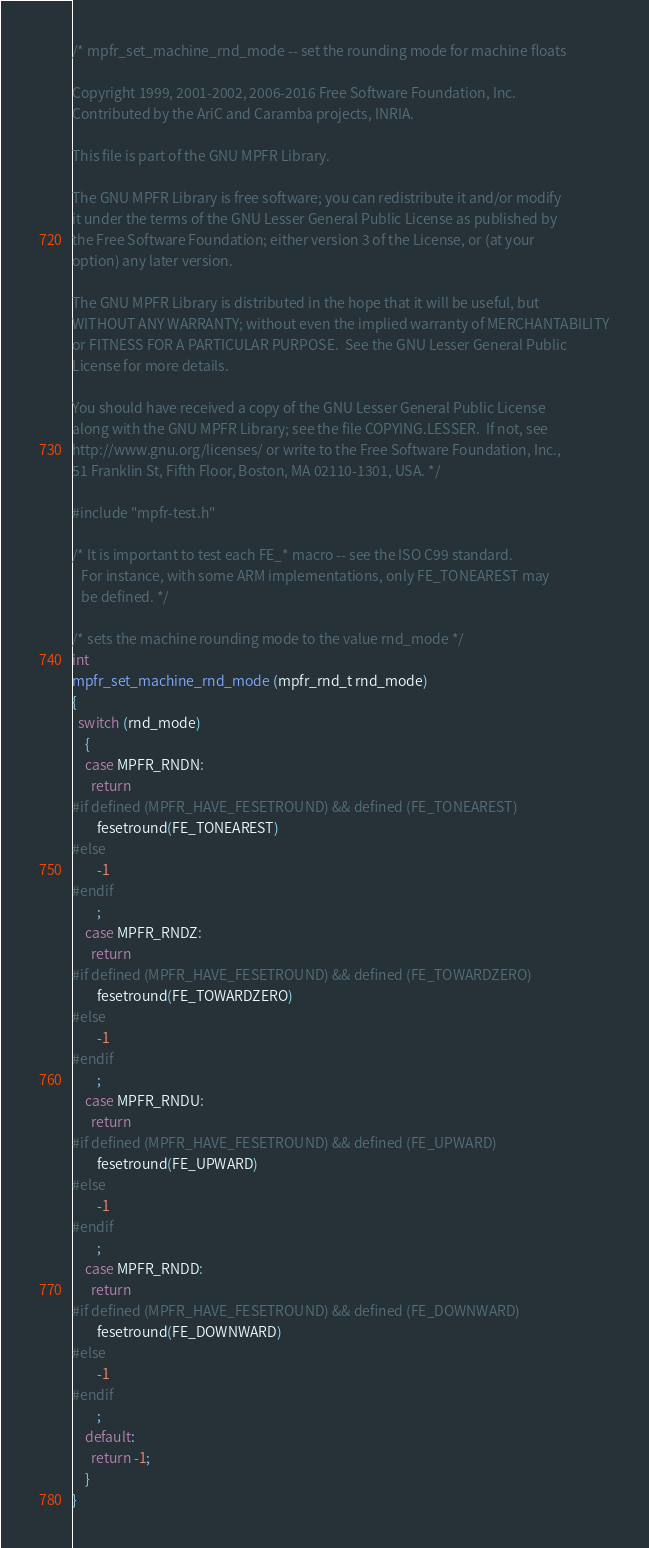Convert code to text. <code><loc_0><loc_0><loc_500><loc_500><_C_>/* mpfr_set_machine_rnd_mode -- set the rounding mode for machine floats

Copyright 1999, 2001-2002, 2006-2016 Free Software Foundation, Inc.
Contributed by the AriC and Caramba projects, INRIA.

This file is part of the GNU MPFR Library.

The GNU MPFR Library is free software; you can redistribute it and/or modify
it under the terms of the GNU Lesser General Public License as published by
the Free Software Foundation; either version 3 of the License, or (at your
option) any later version.

The GNU MPFR Library is distributed in the hope that it will be useful, but
WITHOUT ANY WARRANTY; without even the implied warranty of MERCHANTABILITY
or FITNESS FOR A PARTICULAR PURPOSE.  See the GNU Lesser General Public
License for more details.

You should have received a copy of the GNU Lesser General Public License
along with the GNU MPFR Library; see the file COPYING.LESSER.  If not, see
http://www.gnu.org/licenses/ or write to the Free Software Foundation, Inc.,
51 Franklin St, Fifth Floor, Boston, MA 02110-1301, USA. */

#include "mpfr-test.h"

/* It is important to test each FE_* macro -- see the ISO C99 standard.
   For instance, with some ARM implementations, only FE_TONEAREST may
   be defined. */

/* sets the machine rounding mode to the value rnd_mode */
int
mpfr_set_machine_rnd_mode (mpfr_rnd_t rnd_mode)
{
  switch (rnd_mode)
    {
    case MPFR_RNDN:
      return
#if defined (MPFR_HAVE_FESETROUND) && defined (FE_TONEAREST)
        fesetround(FE_TONEAREST)
#else
        -1
#endif
        ;
    case MPFR_RNDZ:
      return
#if defined (MPFR_HAVE_FESETROUND) && defined (FE_TOWARDZERO)
        fesetround(FE_TOWARDZERO)
#else
        -1
#endif
        ;
    case MPFR_RNDU:
      return
#if defined (MPFR_HAVE_FESETROUND) && defined (FE_UPWARD)
        fesetround(FE_UPWARD)
#else
        -1
#endif
        ;
    case MPFR_RNDD:
      return
#if defined (MPFR_HAVE_FESETROUND) && defined (FE_DOWNWARD)
        fesetround(FE_DOWNWARD)
#else
        -1
#endif
        ;
    default:
      return -1;
    }
}
</code> 